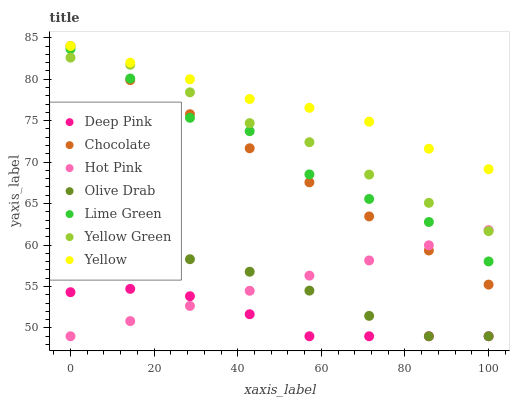Does Deep Pink have the minimum area under the curve?
Answer yes or no. Yes. Does Yellow have the maximum area under the curve?
Answer yes or no. Yes. Does Yellow Green have the minimum area under the curve?
Answer yes or no. No. Does Yellow Green have the maximum area under the curve?
Answer yes or no. No. Is Hot Pink the smoothest?
Answer yes or no. Yes. Is Lime Green the roughest?
Answer yes or no. Yes. Is Yellow Green the smoothest?
Answer yes or no. No. Is Yellow Green the roughest?
Answer yes or no. No. Does Deep Pink have the lowest value?
Answer yes or no. Yes. Does Yellow Green have the lowest value?
Answer yes or no. No. Does Chocolate have the highest value?
Answer yes or no. Yes. Does Yellow Green have the highest value?
Answer yes or no. No. Is Olive Drab less than Yellow?
Answer yes or no. Yes. Is Yellow greater than Lime Green?
Answer yes or no. Yes. Does Chocolate intersect Hot Pink?
Answer yes or no. Yes. Is Chocolate less than Hot Pink?
Answer yes or no. No. Is Chocolate greater than Hot Pink?
Answer yes or no. No. Does Olive Drab intersect Yellow?
Answer yes or no. No. 